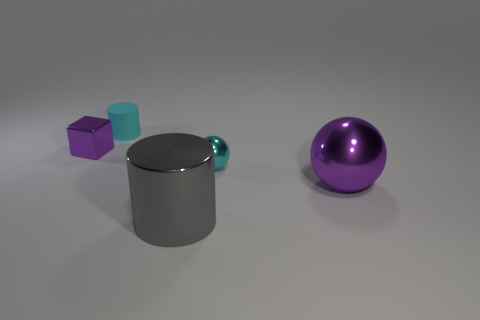How many other things are the same material as the cyan cylinder?
Provide a succinct answer. 0. What number of things are either cylinders on the left side of the large cylinder or big purple things?
Make the answer very short. 2. The purple thing behind the purple shiny object that is to the right of the small rubber cylinder is what shape?
Your answer should be very brief. Cube. There is a cyan thing that is right of the big cylinder; does it have the same shape as the large purple metal object?
Make the answer very short. Yes. What color is the big object in front of the big purple ball?
Your response must be concise. Gray. What number of cubes are gray objects or cyan shiny objects?
Ensure brevity in your answer.  0. There is a purple metal object that is left of the purple object that is in front of the small shiny ball; how big is it?
Give a very brief answer. Small. Do the tiny block and the large thing that is behind the large gray cylinder have the same color?
Offer a very short reply. Yes. There is a purple cube; what number of metallic cylinders are right of it?
Provide a succinct answer. 1. Is the number of cyan balls less than the number of tiny blue matte cylinders?
Ensure brevity in your answer.  No. 